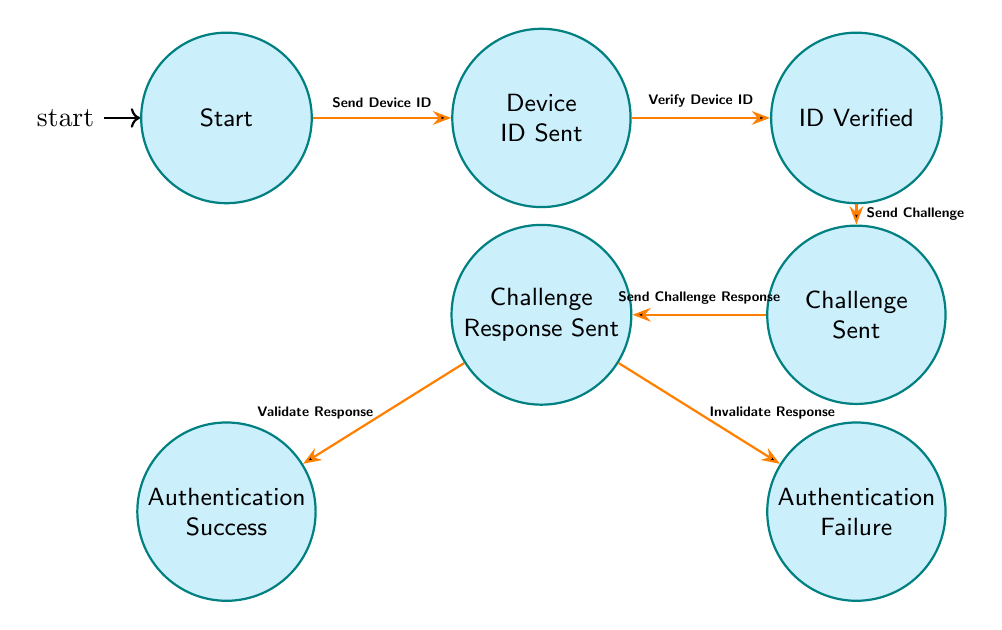What is the initial state of the authentication process? The diagram starts with the state labeled 'Start', which indicates the initial point of the authentication flow for the IoT device.
Answer: Start How many states are represented in the diagram? By counting the labeled states in the diagram, there are a total of seven distinct states effective in the user authentication flow.
Answer: 7 What action transitions from 'Device ID Sent' to 'ID Verified'? The transition is labeled 'Verify Device ID', indicating the action that takes place when the device ID is processed for authentication verification.
Answer: Verify Device ID Which state is reached after 'Challenge Response Sent' if the response is invalid? In this scenario, the diagram shows that an invalid response leads to the state labeled 'Authentication Failure'.
Answer: Authentication Failure What action is performed to validate the device during the authentication process? The action referred to in the diagram for validating the device is labeled 'Validate Response', which occurs after the challenge response is sent.
Answer: Validate Response What is the output of the authentication process if the challenge response sent is validated? If the response is validated, the flow indicates that it will lead to the state 'Authentication Success', marking the successful authentication of the device.
Answer: Authentication Success What state follows 'ID Verified' in the authentication flow? The state that directly follows 'ID Verified' based on the diagram is 'Challenge Sent', which represents the next step in the authentication sequence.
Answer: Challenge Sent Which action goes from 'Challenge Sent' to 'Challenge Response Sent'? The action moving from 'Challenge Sent' to 'Challenge Response Sent' is noted as 'Send Challenge Response', indicating that the device responds to the challenge.
Answer: Send Challenge Response 